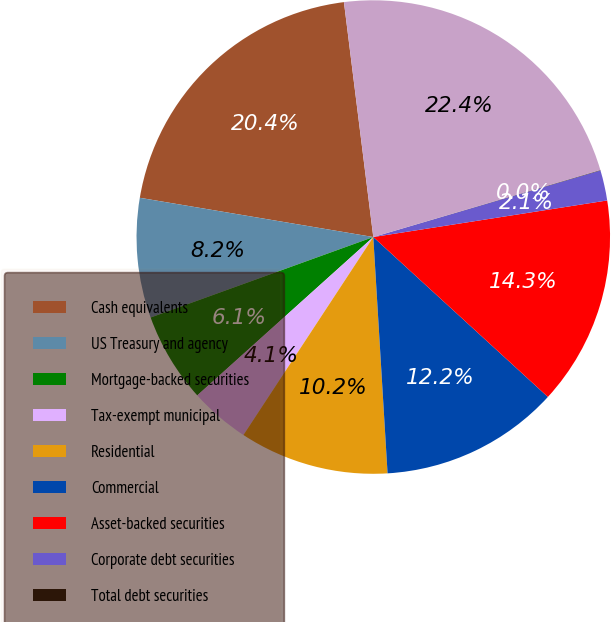Convert chart. <chart><loc_0><loc_0><loc_500><loc_500><pie_chart><fcel>Cash equivalents<fcel>US Treasury and agency<fcel>Mortgage-backed securities<fcel>Tax-exempt municipal<fcel>Residential<fcel>Commercial<fcel>Asset-backed securities<fcel>Corporate debt securities<fcel>Total debt securities<fcel>Total invested assets<nl><fcel>20.37%<fcel>8.17%<fcel>6.14%<fcel>4.1%<fcel>10.2%<fcel>12.24%<fcel>14.27%<fcel>2.07%<fcel>0.03%<fcel>22.41%<nl></chart> 